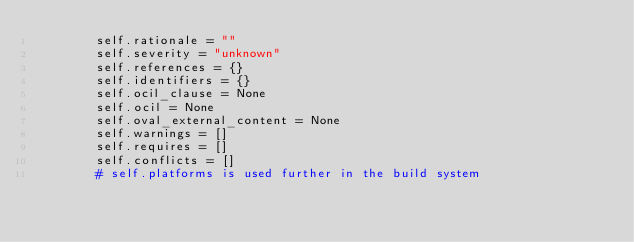Convert code to text. <code><loc_0><loc_0><loc_500><loc_500><_Python_>        self.rationale = ""
        self.severity = "unknown"
        self.references = {}
        self.identifiers = {}
        self.ocil_clause = None
        self.ocil = None
        self.oval_external_content = None
        self.warnings = []
        self.requires = []
        self.conflicts = []
        # self.platforms is used further in the build system</code> 